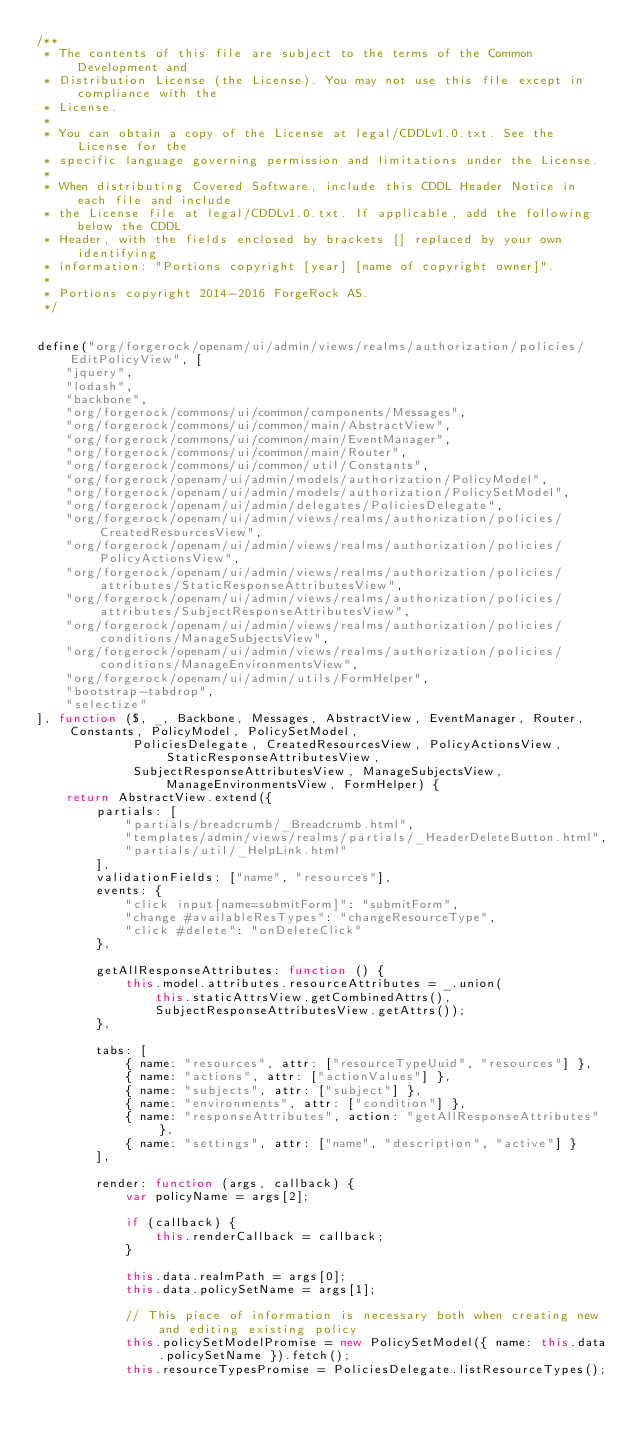<code> <loc_0><loc_0><loc_500><loc_500><_JavaScript_>/**
 * The contents of this file are subject to the terms of the Common Development and
 * Distribution License (the License). You may not use this file except in compliance with the
 * License.
 *
 * You can obtain a copy of the License at legal/CDDLv1.0.txt. See the License for the
 * specific language governing permission and limitations under the License.
 *
 * When distributing Covered Software, include this CDDL Header Notice in each file and include
 * the License file at legal/CDDLv1.0.txt. If applicable, add the following below the CDDL
 * Header, with the fields enclosed by brackets [] replaced by your own identifying
 * information: "Portions copyright [year] [name of copyright owner]".
 *
 * Portions copyright 2014-2016 ForgeRock AS.
 */


define("org/forgerock/openam/ui/admin/views/realms/authorization/policies/EditPolicyView", [
    "jquery",
    "lodash",
    "backbone",
    "org/forgerock/commons/ui/common/components/Messages",
    "org/forgerock/commons/ui/common/main/AbstractView",
    "org/forgerock/commons/ui/common/main/EventManager",
    "org/forgerock/commons/ui/common/main/Router",
    "org/forgerock/commons/ui/common/util/Constants",
    "org/forgerock/openam/ui/admin/models/authorization/PolicyModel",
    "org/forgerock/openam/ui/admin/models/authorization/PolicySetModel",
    "org/forgerock/openam/ui/admin/delegates/PoliciesDelegate",
    "org/forgerock/openam/ui/admin/views/realms/authorization/policies/CreatedResourcesView",
    "org/forgerock/openam/ui/admin/views/realms/authorization/policies/PolicyActionsView",
    "org/forgerock/openam/ui/admin/views/realms/authorization/policies/attributes/StaticResponseAttributesView",
    "org/forgerock/openam/ui/admin/views/realms/authorization/policies/attributes/SubjectResponseAttributesView",
    "org/forgerock/openam/ui/admin/views/realms/authorization/policies/conditions/ManageSubjectsView",
    "org/forgerock/openam/ui/admin/views/realms/authorization/policies/conditions/ManageEnvironmentsView",
    "org/forgerock/openam/ui/admin/utils/FormHelper",
    "bootstrap-tabdrop",
    "selectize"
], function ($, _, Backbone, Messages, AbstractView, EventManager, Router, Constants, PolicyModel, PolicySetModel,
             PoliciesDelegate, CreatedResourcesView, PolicyActionsView, StaticResponseAttributesView,
             SubjectResponseAttributesView, ManageSubjectsView, ManageEnvironmentsView, FormHelper) {
    return AbstractView.extend({
        partials: [
            "partials/breadcrumb/_Breadcrumb.html",
            "templates/admin/views/realms/partials/_HeaderDeleteButton.html",
            "partials/util/_HelpLink.html"
        ],
        validationFields: ["name", "resources"],
        events: {
            "click input[name=submitForm]": "submitForm",
            "change #availableResTypes": "changeResourceType",
            "click #delete": "onDeleteClick"
        },

        getAllResponseAttributes: function () {
            this.model.attributes.resourceAttributes = _.union(
                this.staticAttrsView.getCombinedAttrs(),
                SubjectResponseAttributesView.getAttrs());
        },

        tabs: [
            { name: "resources", attr: ["resourceTypeUuid", "resources"] },
            { name: "actions", attr: ["actionValues"] },
            { name: "subjects", attr: ["subject"] },
            { name: "environments", attr: ["condition"] },
            { name: "responseAttributes", action: "getAllResponseAttributes" },
            { name: "settings", attr: ["name", "description", "active"] }
        ],

        render: function (args, callback) {
            var policyName = args[2];

            if (callback) {
                this.renderCallback = callback;
            }

            this.data.realmPath = args[0];
            this.data.policySetName = args[1];

            // This piece of information is necessary both when creating new and editing existing policy
            this.policySetModelPromise = new PolicySetModel({ name: this.data.policySetName }).fetch();
            this.resourceTypesPromise = PoliciesDelegate.listResourceTypes();
</code> 